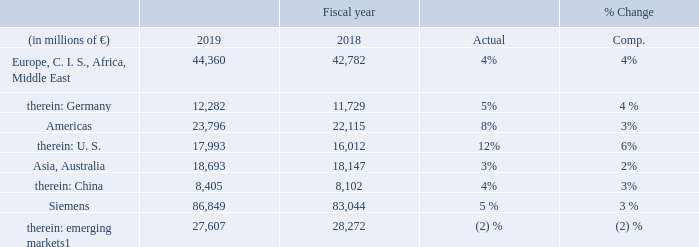1 As defined by the International Monetary Fund.
Revenue related to external customers went up moderately yearover- year on growth in nearly all industrial businesses. SGRE and Siemens Healthineers posted the highest growth rates, while revenue at Gas and Power declined moderately in a difficult market environment. The revenue decline in emerging markets was due mainly to lower revenue in Egypt, where in fiscal 2018 Gas and Power recorded sharply higher revenue from large orders.
Revenue in Europe, C. I. S., Africa, Middle East increased moderately on growth in a majority of industrial businesses, driven by substantial growth at SGRE. Gas and Power posted a clear decline in a difficult market environment. In Germany, revenue was up moderately with significant growth in Mobility and Gas and Power, partly offset by a decline in SGRE.
In the Americas, revenue came in clearly higher year-over-year, benefiting from positive currency translation effects. Siemens Healthineers, Smart Infrastructure and Gas and Power recorded the largest increases, while SGRE posted clearly lower revenue in the region. In the U. S., all industrial businesses posted higher revenues year-over-year, with SGRE and Smart Infrastructure recording the strongest growth rates.
Revenue in Asia, Australia rose moderately year-over-year on growth in the majority of industrial businesses, led by Siemens Healthineers and Digital Industries. Gas and Power and SGRE posted lower revenue year-over-year. In China, revenue was also
up in the majority of industrial businesses, led by Siemens Healthineers. In contrast, SGRE posted substantially lower revenue year-over-year in that country.
What caused the Revenue related to external customers to go up? Revenue related to external customers went up moderately yearover- year on growth in nearly all industrial businesses. What caused the increase in the Revenue in Europe, C. I. S., Africa, Middle East? Revenue in europe, c. i. s., africa, middle east increased moderately on growth in a majority of industrial businesses, driven by substantial growth at sgre. What caused the increase in revenue in Americas? In the americas, revenue came in clearly higher year-over-year, benefiting from positive currency translation effects. What was the average orders in the Americas region in 2019 and 2018?
Answer scale should be: million. (23,796 + 22,115) / 2
Answer: 22955.5. What is the increase / (decrease) in the orders for Asia and Australia from 2018 to 2019?
Answer scale should be: million. 18,693 - 18,147
Answer: 546. What is the percentage increase in the orders for Siemens from 2019 to 2018?
Answer scale should be: percent. 86,849 / 83,044 - 1
Answer: 4.58. 